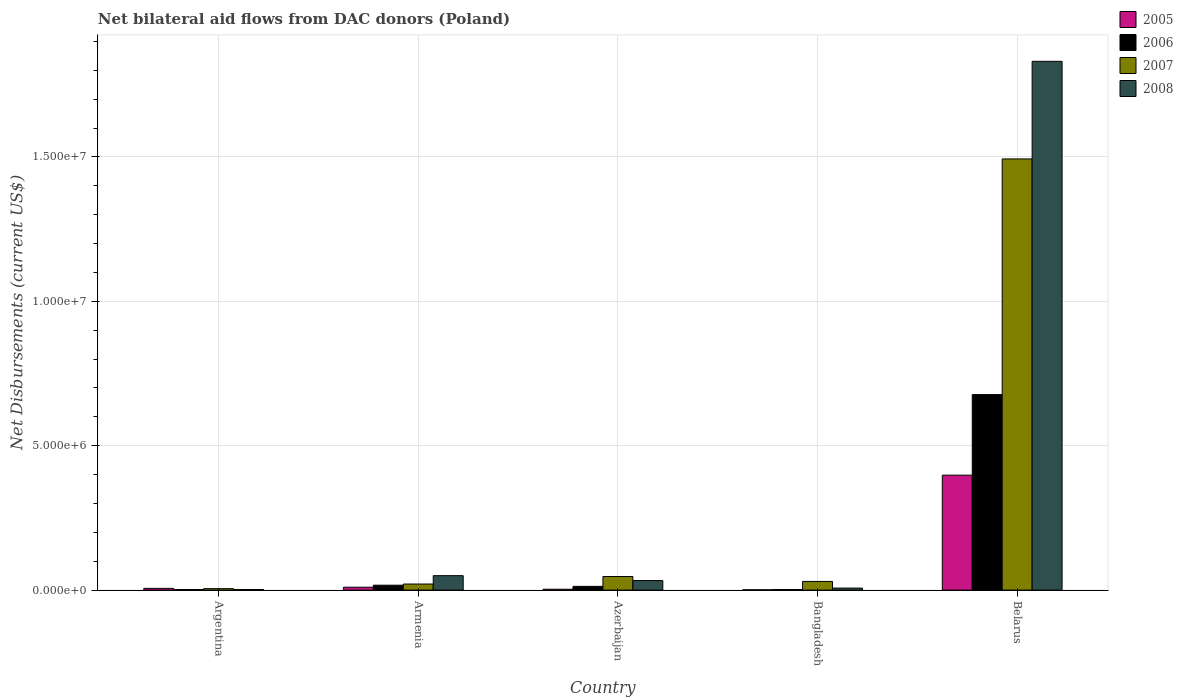How many groups of bars are there?
Keep it short and to the point. 5. Are the number of bars per tick equal to the number of legend labels?
Keep it short and to the point. Yes. Are the number of bars on each tick of the X-axis equal?
Your answer should be compact. Yes. How many bars are there on the 1st tick from the left?
Offer a terse response. 4. What is the label of the 3rd group of bars from the left?
Your answer should be very brief. Azerbaijan. In how many cases, is the number of bars for a given country not equal to the number of legend labels?
Your answer should be very brief. 0. What is the net bilateral aid flows in 2007 in Belarus?
Keep it short and to the point. 1.49e+07. Across all countries, what is the maximum net bilateral aid flows in 2005?
Your response must be concise. 3.98e+06. In which country was the net bilateral aid flows in 2008 maximum?
Provide a succinct answer. Belarus. In which country was the net bilateral aid flows in 2005 minimum?
Offer a terse response. Bangladesh. What is the total net bilateral aid flows in 2008 in the graph?
Make the answer very short. 1.92e+07. What is the difference between the net bilateral aid flows in 2005 in Argentina and that in Belarus?
Keep it short and to the point. -3.92e+06. What is the average net bilateral aid flows in 2007 per country?
Give a very brief answer. 3.19e+06. What is the difference between the net bilateral aid flows of/in 2008 and net bilateral aid flows of/in 2005 in Armenia?
Give a very brief answer. 4.00e+05. In how many countries, is the net bilateral aid flows in 2007 greater than 18000000 US$?
Your response must be concise. 0. What is the ratio of the net bilateral aid flows in 2008 in Argentina to that in Bangladesh?
Offer a terse response. 0.29. Is the net bilateral aid flows in 2008 in Azerbaijan less than that in Belarus?
Give a very brief answer. Yes. What is the difference between the highest and the second highest net bilateral aid flows in 2007?
Your response must be concise. 1.45e+07. What is the difference between the highest and the lowest net bilateral aid flows in 2006?
Make the answer very short. 6.75e+06. In how many countries, is the net bilateral aid flows in 2008 greater than the average net bilateral aid flows in 2008 taken over all countries?
Provide a short and direct response. 1. Is it the case that in every country, the sum of the net bilateral aid flows in 2006 and net bilateral aid flows in 2007 is greater than the sum of net bilateral aid flows in 2005 and net bilateral aid flows in 2008?
Ensure brevity in your answer.  No. What does the 4th bar from the right in Azerbaijan represents?
Offer a terse response. 2005. Are all the bars in the graph horizontal?
Give a very brief answer. No. How many countries are there in the graph?
Keep it short and to the point. 5. What is the difference between two consecutive major ticks on the Y-axis?
Your answer should be very brief. 5.00e+06. Are the values on the major ticks of Y-axis written in scientific E-notation?
Your answer should be compact. Yes. Does the graph contain any zero values?
Offer a very short reply. No. Does the graph contain grids?
Your answer should be compact. Yes. Where does the legend appear in the graph?
Make the answer very short. Top right. How are the legend labels stacked?
Your response must be concise. Vertical. What is the title of the graph?
Provide a short and direct response. Net bilateral aid flows from DAC donors (Poland). Does "1985" appear as one of the legend labels in the graph?
Offer a very short reply. No. What is the label or title of the Y-axis?
Give a very brief answer. Net Disbursements (current US$). What is the Net Disbursements (current US$) in 2005 in Argentina?
Keep it short and to the point. 6.00e+04. What is the Net Disbursements (current US$) in 2006 in Argentina?
Ensure brevity in your answer.  2.00e+04. What is the Net Disbursements (current US$) in 2005 in Armenia?
Make the answer very short. 1.00e+05. What is the Net Disbursements (current US$) in 2007 in Armenia?
Make the answer very short. 2.10e+05. What is the Net Disbursements (current US$) in 2008 in Armenia?
Give a very brief answer. 5.00e+05. What is the Net Disbursements (current US$) of 2005 in Azerbaijan?
Your answer should be very brief. 3.00e+04. What is the Net Disbursements (current US$) of 2007 in Azerbaijan?
Give a very brief answer. 4.70e+05. What is the Net Disbursements (current US$) of 2005 in Bangladesh?
Provide a short and direct response. 10000. What is the Net Disbursements (current US$) of 2006 in Bangladesh?
Your answer should be very brief. 2.00e+04. What is the Net Disbursements (current US$) in 2005 in Belarus?
Provide a succinct answer. 3.98e+06. What is the Net Disbursements (current US$) of 2006 in Belarus?
Provide a succinct answer. 6.77e+06. What is the Net Disbursements (current US$) of 2007 in Belarus?
Make the answer very short. 1.49e+07. What is the Net Disbursements (current US$) of 2008 in Belarus?
Provide a short and direct response. 1.83e+07. Across all countries, what is the maximum Net Disbursements (current US$) in 2005?
Your answer should be very brief. 3.98e+06. Across all countries, what is the maximum Net Disbursements (current US$) in 2006?
Keep it short and to the point. 6.77e+06. Across all countries, what is the maximum Net Disbursements (current US$) in 2007?
Provide a short and direct response. 1.49e+07. Across all countries, what is the maximum Net Disbursements (current US$) of 2008?
Offer a very short reply. 1.83e+07. Across all countries, what is the minimum Net Disbursements (current US$) in 2005?
Offer a very short reply. 10000. Across all countries, what is the minimum Net Disbursements (current US$) of 2006?
Offer a terse response. 2.00e+04. Across all countries, what is the minimum Net Disbursements (current US$) of 2007?
Provide a succinct answer. 5.00e+04. Across all countries, what is the minimum Net Disbursements (current US$) in 2008?
Offer a terse response. 2.00e+04. What is the total Net Disbursements (current US$) in 2005 in the graph?
Offer a very short reply. 4.18e+06. What is the total Net Disbursements (current US$) in 2006 in the graph?
Provide a short and direct response. 7.11e+06. What is the total Net Disbursements (current US$) in 2007 in the graph?
Give a very brief answer. 1.60e+07. What is the total Net Disbursements (current US$) in 2008 in the graph?
Make the answer very short. 1.92e+07. What is the difference between the Net Disbursements (current US$) of 2005 in Argentina and that in Armenia?
Provide a succinct answer. -4.00e+04. What is the difference between the Net Disbursements (current US$) of 2006 in Argentina and that in Armenia?
Your answer should be compact. -1.50e+05. What is the difference between the Net Disbursements (current US$) in 2007 in Argentina and that in Armenia?
Provide a short and direct response. -1.60e+05. What is the difference between the Net Disbursements (current US$) of 2008 in Argentina and that in Armenia?
Make the answer very short. -4.80e+05. What is the difference between the Net Disbursements (current US$) of 2005 in Argentina and that in Azerbaijan?
Offer a terse response. 3.00e+04. What is the difference between the Net Disbursements (current US$) in 2006 in Argentina and that in Azerbaijan?
Offer a very short reply. -1.10e+05. What is the difference between the Net Disbursements (current US$) in 2007 in Argentina and that in Azerbaijan?
Provide a short and direct response. -4.20e+05. What is the difference between the Net Disbursements (current US$) in 2008 in Argentina and that in Azerbaijan?
Your response must be concise. -3.10e+05. What is the difference between the Net Disbursements (current US$) in 2005 in Argentina and that in Bangladesh?
Provide a succinct answer. 5.00e+04. What is the difference between the Net Disbursements (current US$) in 2006 in Argentina and that in Bangladesh?
Provide a succinct answer. 0. What is the difference between the Net Disbursements (current US$) of 2007 in Argentina and that in Bangladesh?
Offer a terse response. -2.50e+05. What is the difference between the Net Disbursements (current US$) in 2008 in Argentina and that in Bangladesh?
Your response must be concise. -5.00e+04. What is the difference between the Net Disbursements (current US$) in 2005 in Argentina and that in Belarus?
Give a very brief answer. -3.92e+06. What is the difference between the Net Disbursements (current US$) in 2006 in Argentina and that in Belarus?
Provide a succinct answer. -6.75e+06. What is the difference between the Net Disbursements (current US$) of 2007 in Argentina and that in Belarus?
Keep it short and to the point. -1.49e+07. What is the difference between the Net Disbursements (current US$) in 2008 in Argentina and that in Belarus?
Your response must be concise. -1.83e+07. What is the difference between the Net Disbursements (current US$) of 2006 in Armenia and that in Azerbaijan?
Your answer should be compact. 4.00e+04. What is the difference between the Net Disbursements (current US$) of 2007 in Armenia and that in Azerbaijan?
Offer a terse response. -2.60e+05. What is the difference between the Net Disbursements (current US$) in 2007 in Armenia and that in Bangladesh?
Ensure brevity in your answer.  -9.00e+04. What is the difference between the Net Disbursements (current US$) in 2008 in Armenia and that in Bangladesh?
Provide a short and direct response. 4.30e+05. What is the difference between the Net Disbursements (current US$) of 2005 in Armenia and that in Belarus?
Provide a succinct answer. -3.88e+06. What is the difference between the Net Disbursements (current US$) of 2006 in Armenia and that in Belarus?
Give a very brief answer. -6.60e+06. What is the difference between the Net Disbursements (current US$) in 2007 in Armenia and that in Belarus?
Your answer should be compact. -1.47e+07. What is the difference between the Net Disbursements (current US$) in 2008 in Armenia and that in Belarus?
Your response must be concise. -1.78e+07. What is the difference between the Net Disbursements (current US$) in 2006 in Azerbaijan and that in Bangladesh?
Your answer should be compact. 1.10e+05. What is the difference between the Net Disbursements (current US$) of 2005 in Azerbaijan and that in Belarus?
Provide a short and direct response. -3.95e+06. What is the difference between the Net Disbursements (current US$) in 2006 in Azerbaijan and that in Belarus?
Your response must be concise. -6.64e+06. What is the difference between the Net Disbursements (current US$) in 2007 in Azerbaijan and that in Belarus?
Offer a very short reply. -1.45e+07. What is the difference between the Net Disbursements (current US$) in 2008 in Azerbaijan and that in Belarus?
Make the answer very short. -1.80e+07. What is the difference between the Net Disbursements (current US$) in 2005 in Bangladesh and that in Belarus?
Offer a very short reply. -3.97e+06. What is the difference between the Net Disbursements (current US$) in 2006 in Bangladesh and that in Belarus?
Keep it short and to the point. -6.75e+06. What is the difference between the Net Disbursements (current US$) of 2007 in Bangladesh and that in Belarus?
Offer a very short reply. -1.46e+07. What is the difference between the Net Disbursements (current US$) in 2008 in Bangladesh and that in Belarus?
Ensure brevity in your answer.  -1.82e+07. What is the difference between the Net Disbursements (current US$) of 2005 in Argentina and the Net Disbursements (current US$) of 2006 in Armenia?
Make the answer very short. -1.10e+05. What is the difference between the Net Disbursements (current US$) of 2005 in Argentina and the Net Disbursements (current US$) of 2007 in Armenia?
Keep it short and to the point. -1.50e+05. What is the difference between the Net Disbursements (current US$) in 2005 in Argentina and the Net Disbursements (current US$) in 2008 in Armenia?
Provide a short and direct response. -4.40e+05. What is the difference between the Net Disbursements (current US$) of 2006 in Argentina and the Net Disbursements (current US$) of 2008 in Armenia?
Keep it short and to the point. -4.80e+05. What is the difference between the Net Disbursements (current US$) of 2007 in Argentina and the Net Disbursements (current US$) of 2008 in Armenia?
Offer a terse response. -4.50e+05. What is the difference between the Net Disbursements (current US$) of 2005 in Argentina and the Net Disbursements (current US$) of 2007 in Azerbaijan?
Provide a short and direct response. -4.10e+05. What is the difference between the Net Disbursements (current US$) of 2005 in Argentina and the Net Disbursements (current US$) of 2008 in Azerbaijan?
Keep it short and to the point. -2.70e+05. What is the difference between the Net Disbursements (current US$) of 2006 in Argentina and the Net Disbursements (current US$) of 2007 in Azerbaijan?
Offer a terse response. -4.50e+05. What is the difference between the Net Disbursements (current US$) in 2006 in Argentina and the Net Disbursements (current US$) in 2008 in Azerbaijan?
Provide a short and direct response. -3.10e+05. What is the difference between the Net Disbursements (current US$) of 2007 in Argentina and the Net Disbursements (current US$) of 2008 in Azerbaijan?
Provide a succinct answer. -2.80e+05. What is the difference between the Net Disbursements (current US$) of 2005 in Argentina and the Net Disbursements (current US$) of 2006 in Bangladesh?
Your response must be concise. 4.00e+04. What is the difference between the Net Disbursements (current US$) in 2005 in Argentina and the Net Disbursements (current US$) in 2007 in Bangladesh?
Provide a succinct answer. -2.40e+05. What is the difference between the Net Disbursements (current US$) in 2005 in Argentina and the Net Disbursements (current US$) in 2008 in Bangladesh?
Make the answer very short. -10000. What is the difference between the Net Disbursements (current US$) in 2006 in Argentina and the Net Disbursements (current US$) in 2007 in Bangladesh?
Your response must be concise. -2.80e+05. What is the difference between the Net Disbursements (current US$) in 2006 in Argentina and the Net Disbursements (current US$) in 2008 in Bangladesh?
Make the answer very short. -5.00e+04. What is the difference between the Net Disbursements (current US$) of 2005 in Argentina and the Net Disbursements (current US$) of 2006 in Belarus?
Give a very brief answer. -6.71e+06. What is the difference between the Net Disbursements (current US$) in 2005 in Argentina and the Net Disbursements (current US$) in 2007 in Belarus?
Offer a terse response. -1.49e+07. What is the difference between the Net Disbursements (current US$) in 2005 in Argentina and the Net Disbursements (current US$) in 2008 in Belarus?
Offer a very short reply. -1.82e+07. What is the difference between the Net Disbursements (current US$) of 2006 in Argentina and the Net Disbursements (current US$) of 2007 in Belarus?
Ensure brevity in your answer.  -1.49e+07. What is the difference between the Net Disbursements (current US$) of 2006 in Argentina and the Net Disbursements (current US$) of 2008 in Belarus?
Provide a succinct answer. -1.83e+07. What is the difference between the Net Disbursements (current US$) of 2007 in Argentina and the Net Disbursements (current US$) of 2008 in Belarus?
Your response must be concise. -1.83e+07. What is the difference between the Net Disbursements (current US$) of 2005 in Armenia and the Net Disbursements (current US$) of 2006 in Azerbaijan?
Offer a terse response. -3.00e+04. What is the difference between the Net Disbursements (current US$) of 2005 in Armenia and the Net Disbursements (current US$) of 2007 in Azerbaijan?
Your answer should be compact. -3.70e+05. What is the difference between the Net Disbursements (current US$) of 2005 in Armenia and the Net Disbursements (current US$) of 2008 in Azerbaijan?
Your answer should be compact. -2.30e+05. What is the difference between the Net Disbursements (current US$) in 2006 in Armenia and the Net Disbursements (current US$) in 2007 in Azerbaijan?
Ensure brevity in your answer.  -3.00e+05. What is the difference between the Net Disbursements (current US$) in 2005 in Armenia and the Net Disbursements (current US$) in 2008 in Bangladesh?
Give a very brief answer. 3.00e+04. What is the difference between the Net Disbursements (current US$) of 2007 in Armenia and the Net Disbursements (current US$) of 2008 in Bangladesh?
Give a very brief answer. 1.40e+05. What is the difference between the Net Disbursements (current US$) of 2005 in Armenia and the Net Disbursements (current US$) of 2006 in Belarus?
Your answer should be very brief. -6.67e+06. What is the difference between the Net Disbursements (current US$) in 2005 in Armenia and the Net Disbursements (current US$) in 2007 in Belarus?
Your answer should be compact. -1.48e+07. What is the difference between the Net Disbursements (current US$) of 2005 in Armenia and the Net Disbursements (current US$) of 2008 in Belarus?
Your answer should be compact. -1.82e+07. What is the difference between the Net Disbursements (current US$) in 2006 in Armenia and the Net Disbursements (current US$) in 2007 in Belarus?
Make the answer very short. -1.48e+07. What is the difference between the Net Disbursements (current US$) of 2006 in Armenia and the Net Disbursements (current US$) of 2008 in Belarus?
Ensure brevity in your answer.  -1.81e+07. What is the difference between the Net Disbursements (current US$) in 2007 in Armenia and the Net Disbursements (current US$) in 2008 in Belarus?
Ensure brevity in your answer.  -1.81e+07. What is the difference between the Net Disbursements (current US$) of 2005 in Azerbaijan and the Net Disbursements (current US$) of 2008 in Bangladesh?
Offer a terse response. -4.00e+04. What is the difference between the Net Disbursements (current US$) in 2006 in Azerbaijan and the Net Disbursements (current US$) in 2008 in Bangladesh?
Your response must be concise. 6.00e+04. What is the difference between the Net Disbursements (current US$) of 2007 in Azerbaijan and the Net Disbursements (current US$) of 2008 in Bangladesh?
Give a very brief answer. 4.00e+05. What is the difference between the Net Disbursements (current US$) of 2005 in Azerbaijan and the Net Disbursements (current US$) of 2006 in Belarus?
Provide a short and direct response. -6.74e+06. What is the difference between the Net Disbursements (current US$) of 2005 in Azerbaijan and the Net Disbursements (current US$) of 2007 in Belarus?
Your response must be concise. -1.49e+07. What is the difference between the Net Disbursements (current US$) of 2005 in Azerbaijan and the Net Disbursements (current US$) of 2008 in Belarus?
Your answer should be compact. -1.83e+07. What is the difference between the Net Disbursements (current US$) of 2006 in Azerbaijan and the Net Disbursements (current US$) of 2007 in Belarus?
Your answer should be very brief. -1.48e+07. What is the difference between the Net Disbursements (current US$) of 2006 in Azerbaijan and the Net Disbursements (current US$) of 2008 in Belarus?
Your response must be concise. -1.82e+07. What is the difference between the Net Disbursements (current US$) of 2007 in Azerbaijan and the Net Disbursements (current US$) of 2008 in Belarus?
Your answer should be very brief. -1.78e+07. What is the difference between the Net Disbursements (current US$) of 2005 in Bangladesh and the Net Disbursements (current US$) of 2006 in Belarus?
Offer a very short reply. -6.76e+06. What is the difference between the Net Disbursements (current US$) in 2005 in Bangladesh and the Net Disbursements (current US$) in 2007 in Belarus?
Offer a terse response. -1.49e+07. What is the difference between the Net Disbursements (current US$) in 2005 in Bangladesh and the Net Disbursements (current US$) in 2008 in Belarus?
Provide a succinct answer. -1.83e+07. What is the difference between the Net Disbursements (current US$) of 2006 in Bangladesh and the Net Disbursements (current US$) of 2007 in Belarus?
Make the answer very short. -1.49e+07. What is the difference between the Net Disbursements (current US$) of 2006 in Bangladesh and the Net Disbursements (current US$) of 2008 in Belarus?
Offer a terse response. -1.83e+07. What is the difference between the Net Disbursements (current US$) in 2007 in Bangladesh and the Net Disbursements (current US$) in 2008 in Belarus?
Your response must be concise. -1.80e+07. What is the average Net Disbursements (current US$) in 2005 per country?
Your response must be concise. 8.36e+05. What is the average Net Disbursements (current US$) in 2006 per country?
Give a very brief answer. 1.42e+06. What is the average Net Disbursements (current US$) in 2007 per country?
Your answer should be very brief. 3.19e+06. What is the average Net Disbursements (current US$) in 2008 per country?
Offer a terse response. 3.85e+06. What is the difference between the Net Disbursements (current US$) of 2005 and Net Disbursements (current US$) of 2007 in Argentina?
Your answer should be very brief. 10000. What is the difference between the Net Disbursements (current US$) of 2005 and Net Disbursements (current US$) of 2008 in Armenia?
Your response must be concise. -4.00e+05. What is the difference between the Net Disbursements (current US$) in 2006 and Net Disbursements (current US$) in 2008 in Armenia?
Ensure brevity in your answer.  -3.30e+05. What is the difference between the Net Disbursements (current US$) in 2007 and Net Disbursements (current US$) in 2008 in Armenia?
Provide a short and direct response. -2.90e+05. What is the difference between the Net Disbursements (current US$) of 2005 and Net Disbursements (current US$) of 2007 in Azerbaijan?
Provide a short and direct response. -4.40e+05. What is the difference between the Net Disbursements (current US$) of 2005 and Net Disbursements (current US$) of 2008 in Azerbaijan?
Give a very brief answer. -3.00e+05. What is the difference between the Net Disbursements (current US$) in 2006 and Net Disbursements (current US$) in 2007 in Azerbaijan?
Offer a very short reply. -3.40e+05. What is the difference between the Net Disbursements (current US$) of 2006 and Net Disbursements (current US$) of 2008 in Azerbaijan?
Make the answer very short. -2.00e+05. What is the difference between the Net Disbursements (current US$) of 2006 and Net Disbursements (current US$) of 2007 in Bangladesh?
Your answer should be very brief. -2.80e+05. What is the difference between the Net Disbursements (current US$) in 2006 and Net Disbursements (current US$) in 2008 in Bangladesh?
Your answer should be very brief. -5.00e+04. What is the difference between the Net Disbursements (current US$) of 2005 and Net Disbursements (current US$) of 2006 in Belarus?
Your answer should be very brief. -2.79e+06. What is the difference between the Net Disbursements (current US$) in 2005 and Net Disbursements (current US$) in 2007 in Belarus?
Make the answer very short. -1.10e+07. What is the difference between the Net Disbursements (current US$) in 2005 and Net Disbursements (current US$) in 2008 in Belarus?
Your response must be concise. -1.43e+07. What is the difference between the Net Disbursements (current US$) in 2006 and Net Disbursements (current US$) in 2007 in Belarus?
Offer a terse response. -8.16e+06. What is the difference between the Net Disbursements (current US$) in 2006 and Net Disbursements (current US$) in 2008 in Belarus?
Provide a succinct answer. -1.15e+07. What is the difference between the Net Disbursements (current US$) of 2007 and Net Disbursements (current US$) of 2008 in Belarus?
Ensure brevity in your answer.  -3.38e+06. What is the ratio of the Net Disbursements (current US$) of 2006 in Argentina to that in Armenia?
Make the answer very short. 0.12. What is the ratio of the Net Disbursements (current US$) in 2007 in Argentina to that in Armenia?
Provide a short and direct response. 0.24. What is the ratio of the Net Disbursements (current US$) of 2008 in Argentina to that in Armenia?
Your answer should be compact. 0.04. What is the ratio of the Net Disbursements (current US$) in 2006 in Argentina to that in Azerbaijan?
Ensure brevity in your answer.  0.15. What is the ratio of the Net Disbursements (current US$) of 2007 in Argentina to that in Azerbaijan?
Provide a succinct answer. 0.11. What is the ratio of the Net Disbursements (current US$) of 2008 in Argentina to that in Azerbaijan?
Provide a short and direct response. 0.06. What is the ratio of the Net Disbursements (current US$) in 2005 in Argentina to that in Bangladesh?
Your answer should be very brief. 6. What is the ratio of the Net Disbursements (current US$) of 2008 in Argentina to that in Bangladesh?
Your response must be concise. 0.29. What is the ratio of the Net Disbursements (current US$) in 2005 in Argentina to that in Belarus?
Give a very brief answer. 0.02. What is the ratio of the Net Disbursements (current US$) of 2006 in Argentina to that in Belarus?
Make the answer very short. 0. What is the ratio of the Net Disbursements (current US$) in 2007 in Argentina to that in Belarus?
Your answer should be compact. 0. What is the ratio of the Net Disbursements (current US$) of 2008 in Argentina to that in Belarus?
Keep it short and to the point. 0. What is the ratio of the Net Disbursements (current US$) of 2006 in Armenia to that in Azerbaijan?
Make the answer very short. 1.31. What is the ratio of the Net Disbursements (current US$) of 2007 in Armenia to that in Azerbaijan?
Provide a succinct answer. 0.45. What is the ratio of the Net Disbursements (current US$) in 2008 in Armenia to that in Azerbaijan?
Provide a succinct answer. 1.52. What is the ratio of the Net Disbursements (current US$) of 2005 in Armenia to that in Bangladesh?
Offer a very short reply. 10. What is the ratio of the Net Disbursements (current US$) in 2006 in Armenia to that in Bangladesh?
Give a very brief answer. 8.5. What is the ratio of the Net Disbursements (current US$) of 2008 in Armenia to that in Bangladesh?
Provide a succinct answer. 7.14. What is the ratio of the Net Disbursements (current US$) of 2005 in Armenia to that in Belarus?
Offer a very short reply. 0.03. What is the ratio of the Net Disbursements (current US$) in 2006 in Armenia to that in Belarus?
Ensure brevity in your answer.  0.03. What is the ratio of the Net Disbursements (current US$) of 2007 in Armenia to that in Belarus?
Your answer should be compact. 0.01. What is the ratio of the Net Disbursements (current US$) in 2008 in Armenia to that in Belarus?
Make the answer very short. 0.03. What is the ratio of the Net Disbursements (current US$) of 2007 in Azerbaijan to that in Bangladesh?
Ensure brevity in your answer.  1.57. What is the ratio of the Net Disbursements (current US$) in 2008 in Azerbaijan to that in Bangladesh?
Give a very brief answer. 4.71. What is the ratio of the Net Disbursements (current US$) of 2005 in Azerbaijan to that in Belarus?
Ensure brevity in your answer.  0.01. What is the ratio of the Net Disbursements (current US$) in 2006 in Azerbaijan to that in Belarus?
Your response must be concise. 0.02. What is the ratio of the Net Disbursements (current US$) of 2007 in Azerbaijan to that in Belarus?
Your answer should be very brief. 0.03. What is the ratio of the Net Disbursements (current US$) in 2008 in Azerbaijan to that in Belarus?
Offer a very short reply. 0.02. What is the ratio of the Net Disbursements (current US$) in 2005 in Bangladesh to that in Belarus?
Provide a short and direct response. 0. What is the ratio of the Net Disbursements (current US$) of 2006 in Bangladesh to that in Belarus?
Give a very brief answer. 0. What is the ratio of the Net Disbursements (current US$) of 2007 in Bangladesh to that in Belarus?
Give a very brief answer. 0.02. What is the ratio of the Net Disbursements (current US$) in 2008 in Bangladesh to that in Belarus?
Ensure brevity in your answer.  0. What is the difference between the highest and the second highest Net Disbursements (current US$) of 2005?
Provide a short and direct response. 3.88e+06. What is the difference between the highest and the second highest Net Disbursements (current US$) of 2006?
Your answer should be very brief. 6.60e+06. What is the difference between the highest and the second highest Net Disbursements (current US$) of 2007?
Your response must be concise. 1.45e+07. What is the difference between the highest and the second highest Net Disbursements (current US$) of 2008?
Ensure brevity in your answer.  1.78e+07. What is the difference between the highest and the lowest Net Disbursements (current US$) in 2005?
Provide a succinct answer. 3.97e+06. What is the difference between the highest and the lowest Net Disbursements (current US$) in 2006?
Provide a succinct answer. 6.75e+06. What is the difference between the highest and the lowest Net Disbursements (current US$) of 2007?
Ensure brevity in your answer.  1.49e+07. What is the difference between the highest and the lowest Net Disbursements (current US$) of 2008?
Keep it short and to the point. 1.83e+07. 